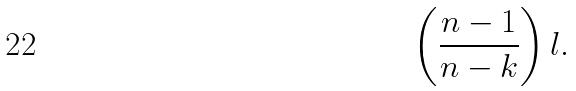Convert formula to latex. <formula><loc_0><loc_0><loc_500><loc_500>\left ( \frac { n - 1 } { n - k } \right ) l .</formula> 